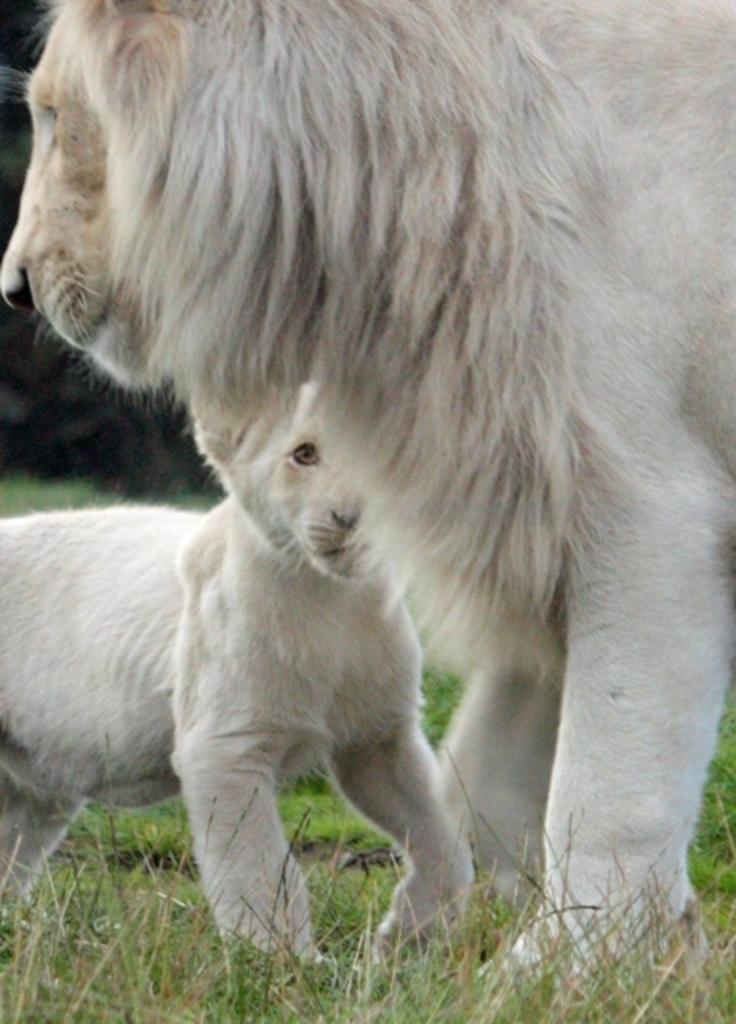How would you summarize this image in a sentence or two? Here we can see a White lion and white cub on the grass. 